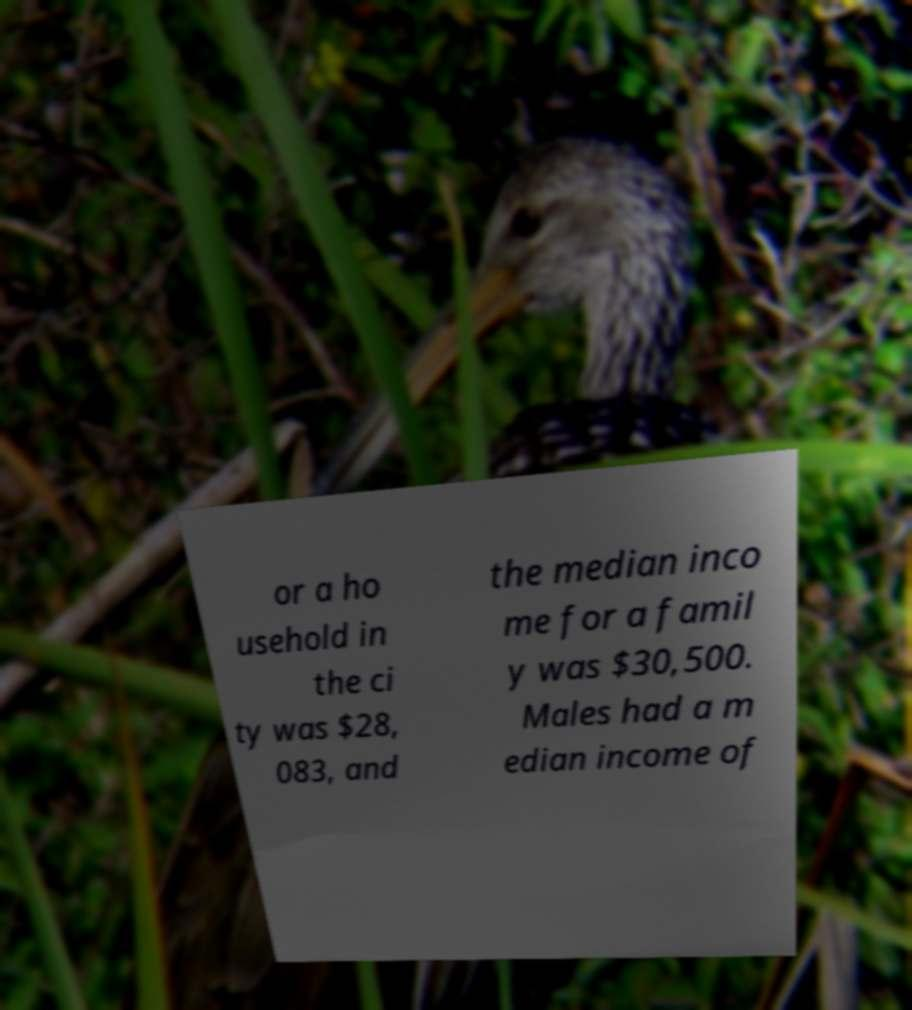What messages or text are displayed in this image? I need them in a readable, typed format. or a ho usehold in the ci ty was $28, 083, and the median inco me for a famil y was $30,500. Males had a m edian income of 